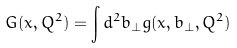Convert formula to latex. <formula><loc_0><loc_0><loc_500><loc_500>G ( x , Q ^ { 2 } ) = \int d ^ { 2 } b _ { \perp } g ( x , b _ { \perp } , Q ^ { 2 } )</formula> 